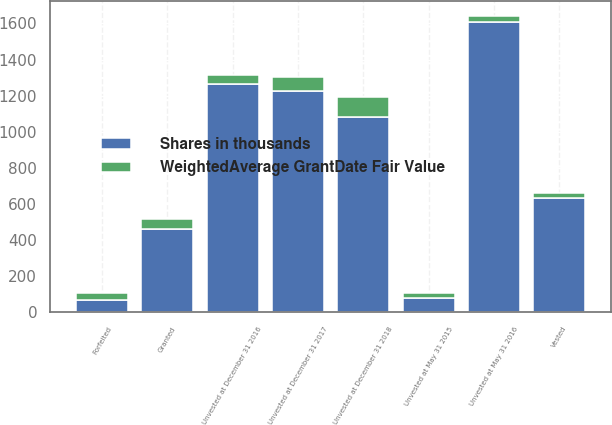Convert chart to OTSL. <chart><loc_0><loc_0><loc_500><loc_500><stacked_bar_chart><ecel><fcel>Unvested at May 31 2015<fcel>Granted<fcel>Vested<fcel>Forfeited<fcel>Unvested at May 31 2016<fcel>Unvested at December 31 2016<fcel>Unvested at December 31 2017<fcel>Unvested at December 31 2018<nl><fcel>Shares in thousands<fcel>78.29<fcel>461<fcel>633<fcel>70<fcel>1606<fcel>1263<fcel>1226<fcel>1084<nl><fcel>WeightedAverage GrantDate Fair Value<fcel>28.97<fcel>57.04<fcel>27.55<fcel>34.69<fcel>37.25<fcel>49.55<fcel>78.29<fcel>108.51<nl></chart> 